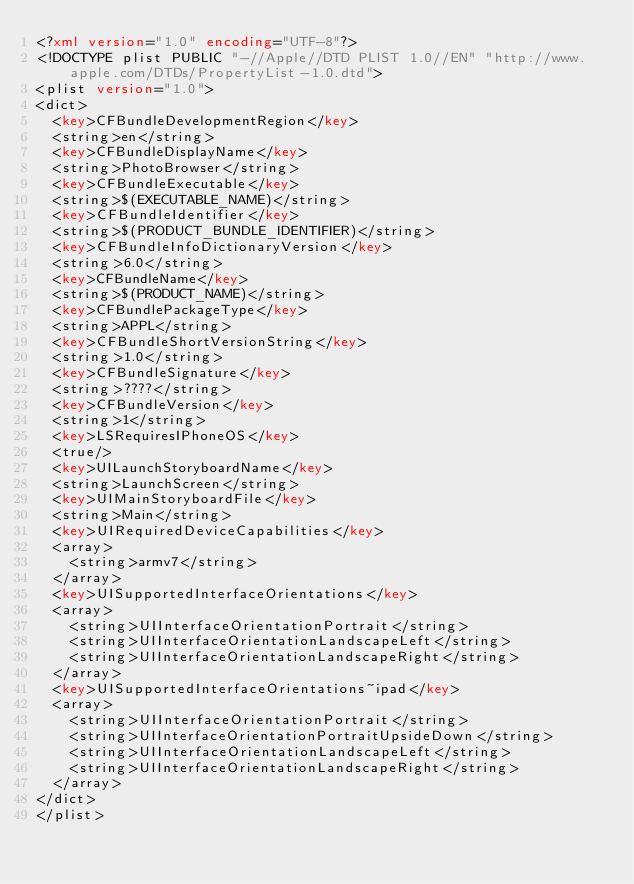<code> <loc_0><loc_0><loc_500><loc_500><_XML_><?xml version="1.0" encoding="UTF-8"?>
<!DOCTYPE plist PUBLIC "-//Apple//DTD PLIST 1.0//EN" "http://www.apple.com/DTDs/PropertyList-1.0.dtd">
<plist version="1.0">
<dict>
	<key>CFBundleDevelopmentRegion</key>
	<string>en</string>
	<key>CFBundleDisplayName</key>
	<string>PhotoBrowser</string>
	<key>CFBundleExecutable</key>
	<string>$(EXECUTABLE_NAME)</string>
	<key>CFBundleIdentifier</key>
	<string>$(PRODUCT_BUNDLE_IDENTIFIER)</string>
	<key>CFBundleInfoDictionaryVersion</key>
	<string>6.0</string>
	<key>CFBundleName</key>
	<string>$(PRODUCT_NAME)</string>
	<key>CFBundlePackageType</key>
	<string>APPL</string>
	<key>CFBundleShortVersionString</key>
	<string>1.0</string>
	<key>CFBundleSignature</key>
	<string>????</string>
	<key>CFBundleVersion</key>
	<string>1</string>
	<key>LSRequiresIPhoneOS</key>
	<true/>
	<key>UILaunchStoryboardName</key>
	<string>LaunchScreen</string>
	<key>UIMainStoryboardFile</key>
	<string>Main</string>
	<key>UIRequiredDeviceCapabilities</key>
	<array>
		<string>armv7</string>
	</array>
	<key>UISupportedInterfaceOrientations</key>
	<array>
		<string>UIInterfaceOrientationPortrait</string>
		<string>UIInterfaceOrientationLandscapeLeft</string>
		<string>UIInterfaceOrientationLandscapeRight</string>
	</array>
	<key>UISupportedInterfaceOrientations~ipad</key>
	<array>
		<string>UIInterfaceOrientationPortrait</string>
		<string>UIInterfaceOrientationPortraitUpsideDown</string>
		<string>UIInterfaceOrientationLandscapeLeft</string>
		<string>UIInterfaceOrientationLandscapeRight</string>
	</array>
</dict>
</plist>
</code> 